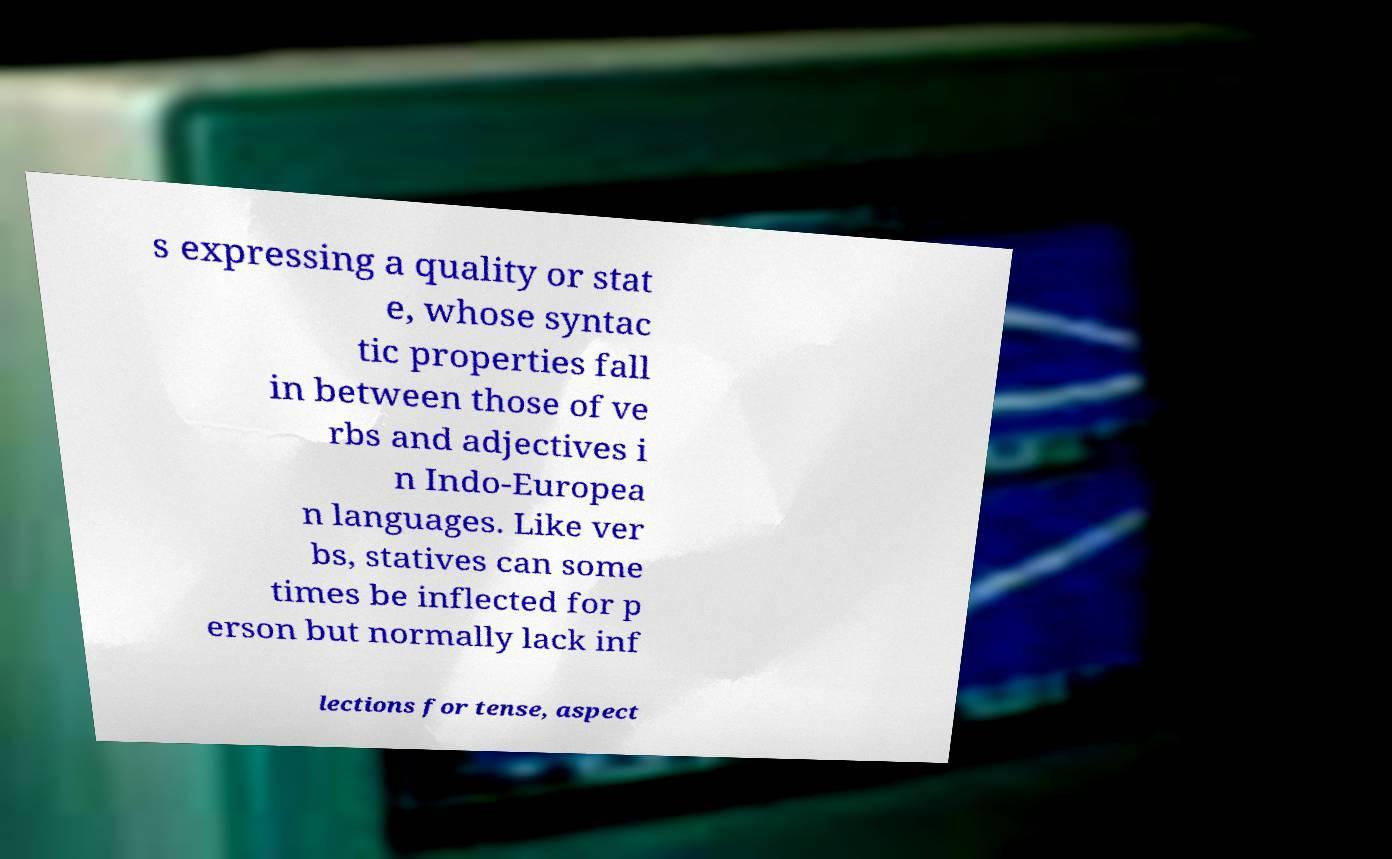I need the written content from this picture converted into text. Can you do that? s expressing a quality or stat e, whose syntac tic properties fall in between those of ve rbs and adjectives i n Indo-Europea n languages. Like ver bs, statives can some times be inflected for p erson but normally lack inf lections for tense, aspect 